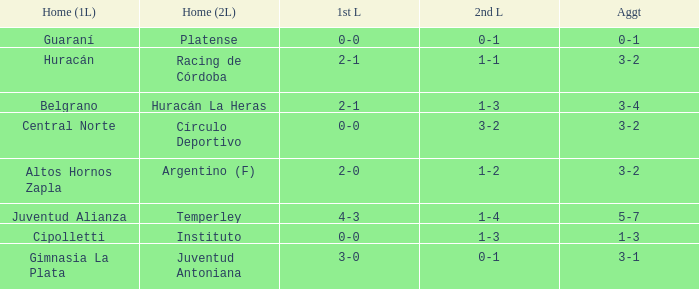What was the combined score featuring a 1-2 second leg score? 3-2. 